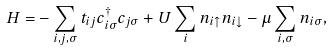Convert formula to latex. <formula><loc_0><loc_0><loc_500><loc_500>H = & - \sum _ { i , j , \sigma } t _ { i j } c _ { i \sigma } ^ { \dag } c _ { j \sigma } + U \sum _ { i } n _ { i \uparrow } n _ { i \downarrow } - \mu \sum _ { i , \sigma } n _ { i \sigma } ,</formula> 